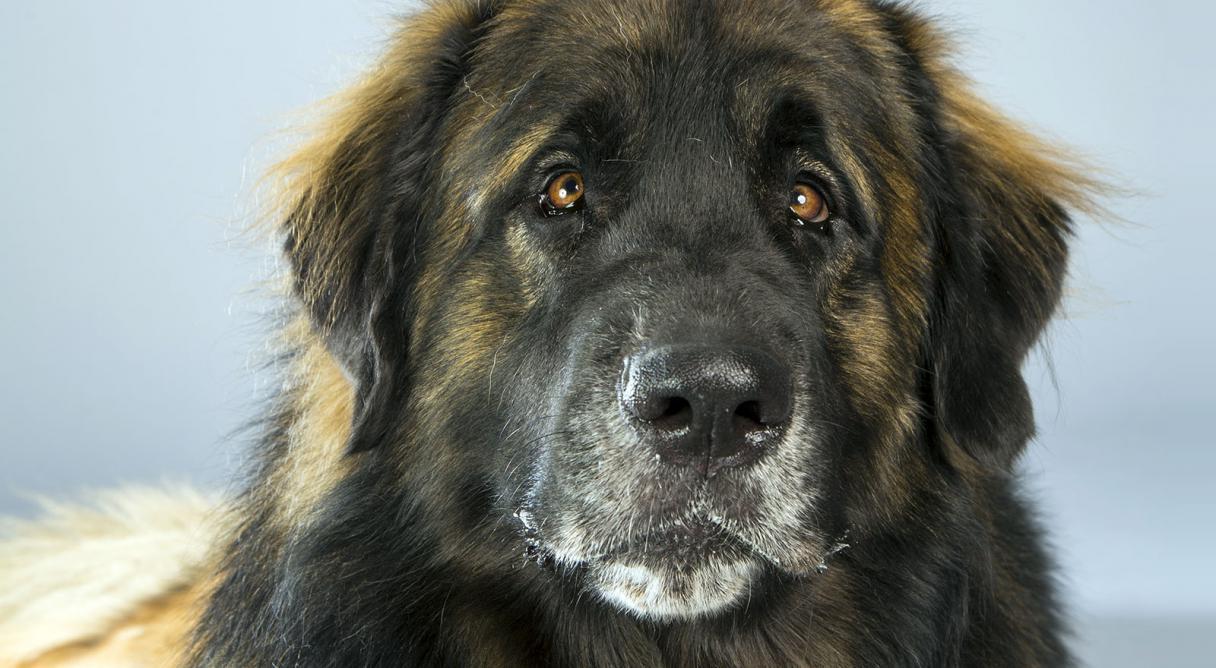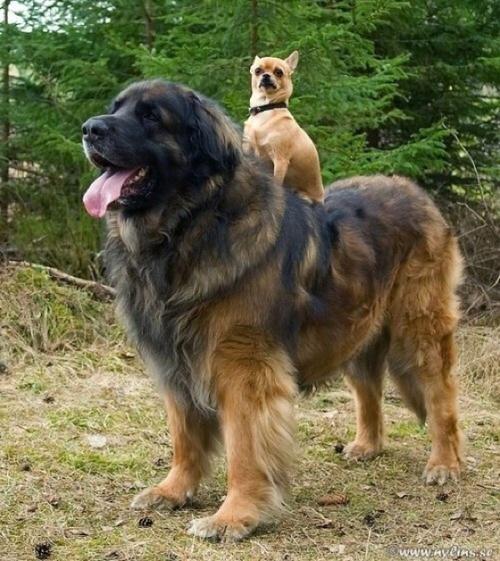The first image is the image on the left, the second image is the image on the right. Considering the images on both sides, is "One dog is sitting in the short grass in the image on the left." valid? Answer yes or no. No. The first image is the image on the left, the second image is the image on the right. Evaluate the accuracy of this statement regarding the images: "Right image contains more dogs than the left image.". Is it true? Answer yes or no. Yes. 